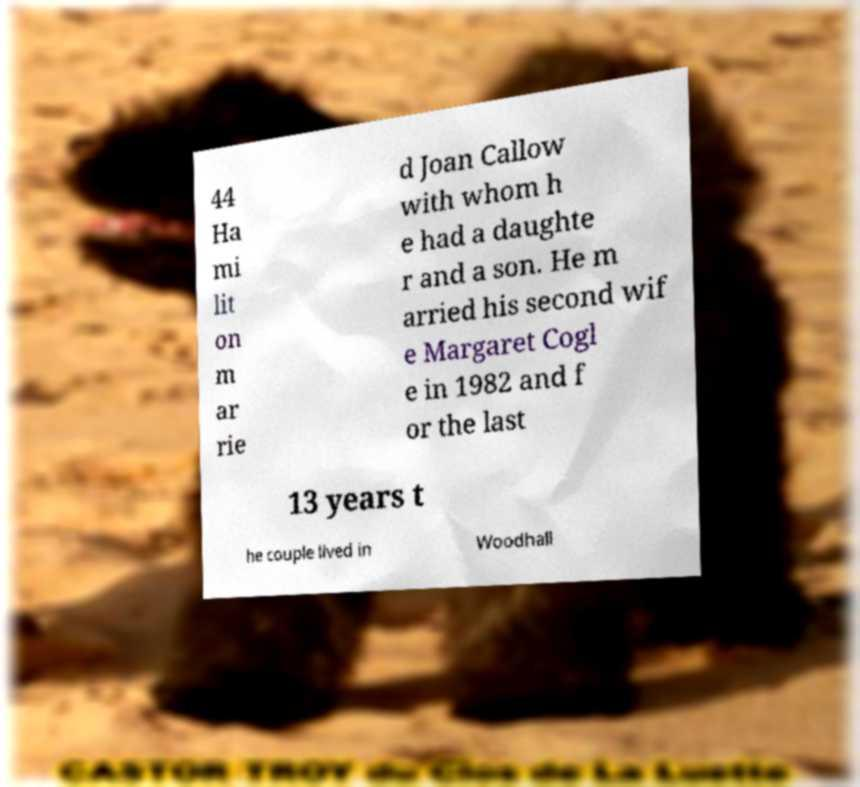Can you accurately transcribe the text from the provided image for me? 44 Ha mi lit on m ar rie d Joan Callow with whom h e had a daughte r and a son. He m arried his second wif e Margaret Cogl e in 1982 and f or the last 13 years t he couple lived in Woodhall 